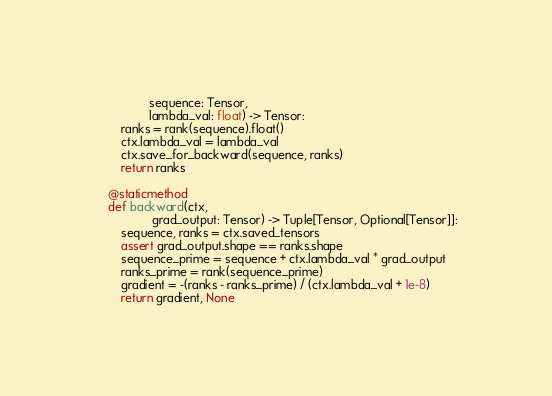<code> <loc_0><loc_0><loc_500><loc_500><_Python_>                sequence: Tensor,
                lambda_val: float) -> Tensor:
        ranks = rank(sequence).float()
        ctx.lambda_val = lambda_val
        ctx.save_for_backward(sequence, ranks)
        return ranks

    @staticmethod
    def backward(ctx,
                 grad_output: Tensor) -> Tuple[Tensor, Optional[Tensor]]:
        sequence, ranks = ctx.saved_tensors
        assert grad_output.shape == ranks.shape
        sequence_prime = sequence + ctx.lambda_val * grad_output
        ranks_prime = rank(sequence_prime)
        gradient = -(ranks - ranks_prime) / (ctx.lambda_val + 1e-8)
        return gradient, None
</code> 